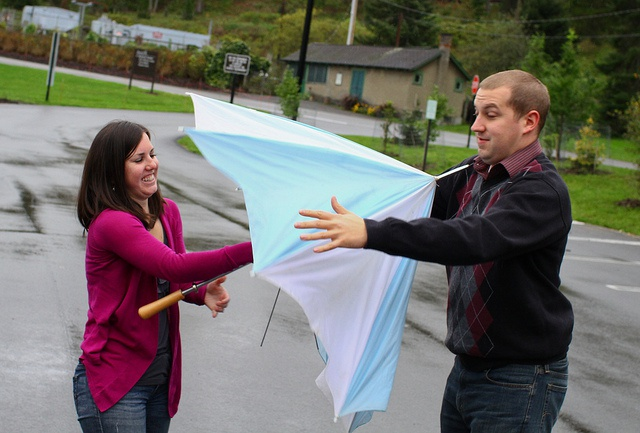Describe the objects in this image and their specific colors. I can see people in darkgreen, black, brown, gray, and maroon tones, umbrella in darkgreen, lightblue, lavender, and darkgray tones, people in darkgreen, black, maroon, purple, and gray tones, and stop sign in darkgreen, brown, and salmon tones in this image. 